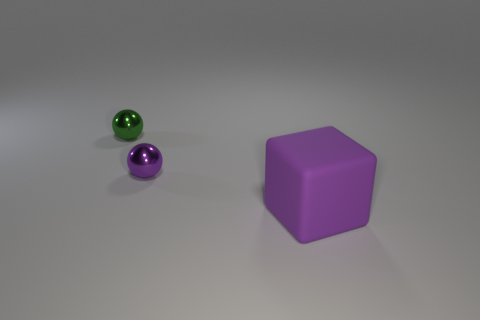What is the shape of the large purple thing?
Ensure brevity in your answer.  Cube. Does the small thing in front of the green ball have the same material as the large purple block?
Your answer should be compact. No. What size is the purple thing that is in front of the purple object behind the big purple block?
Keep it short and to the point. Large. What is the color of the object that is to the left of the block and right of the green metallic sphere?
Provide a short and direct response. Purple. There is a object that is the same size as the green shiny sphere; what is its material?
Ensure brevity in your answer.  Metal. How many other things are there of the same material as the tiny purple object?
Your answer should be very brief. 1. Is the color of the metallic thing in front of the green metal thing the same as the object in front of the tiny purple metal thing?
Your response must be concise. Yes. There is a purple object that is on the right side of the tiny object that is to the right of the small green shiny ball; what shape is it?
Offer a terse response. Cube. Does the purple thing that is to the left of the purple block have the same material as the purple thing that is in front of the tiny purple sphere?
Your answer should be very brief. No. How big is the object that is in front of the small purple metal ball?
Ensure brevity in your answer.  Large. 